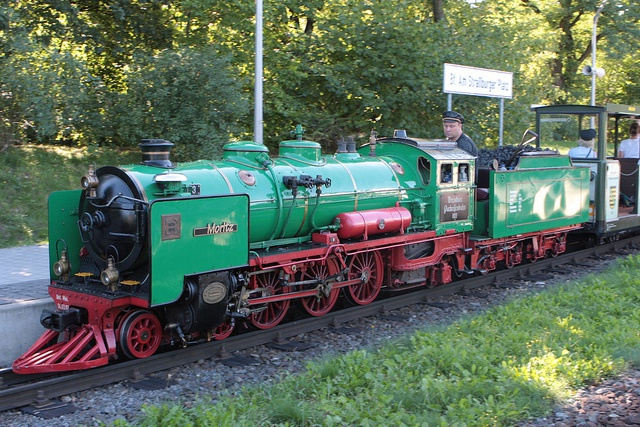Describe the objects in this image and their specific colors. I can see train in black, teal, and gray tones, people in black, gray, darkgray, and blue tones, people in black, lavender, and gray tones, and people in black, lightblue, darkgray, and navy tones in this image. 